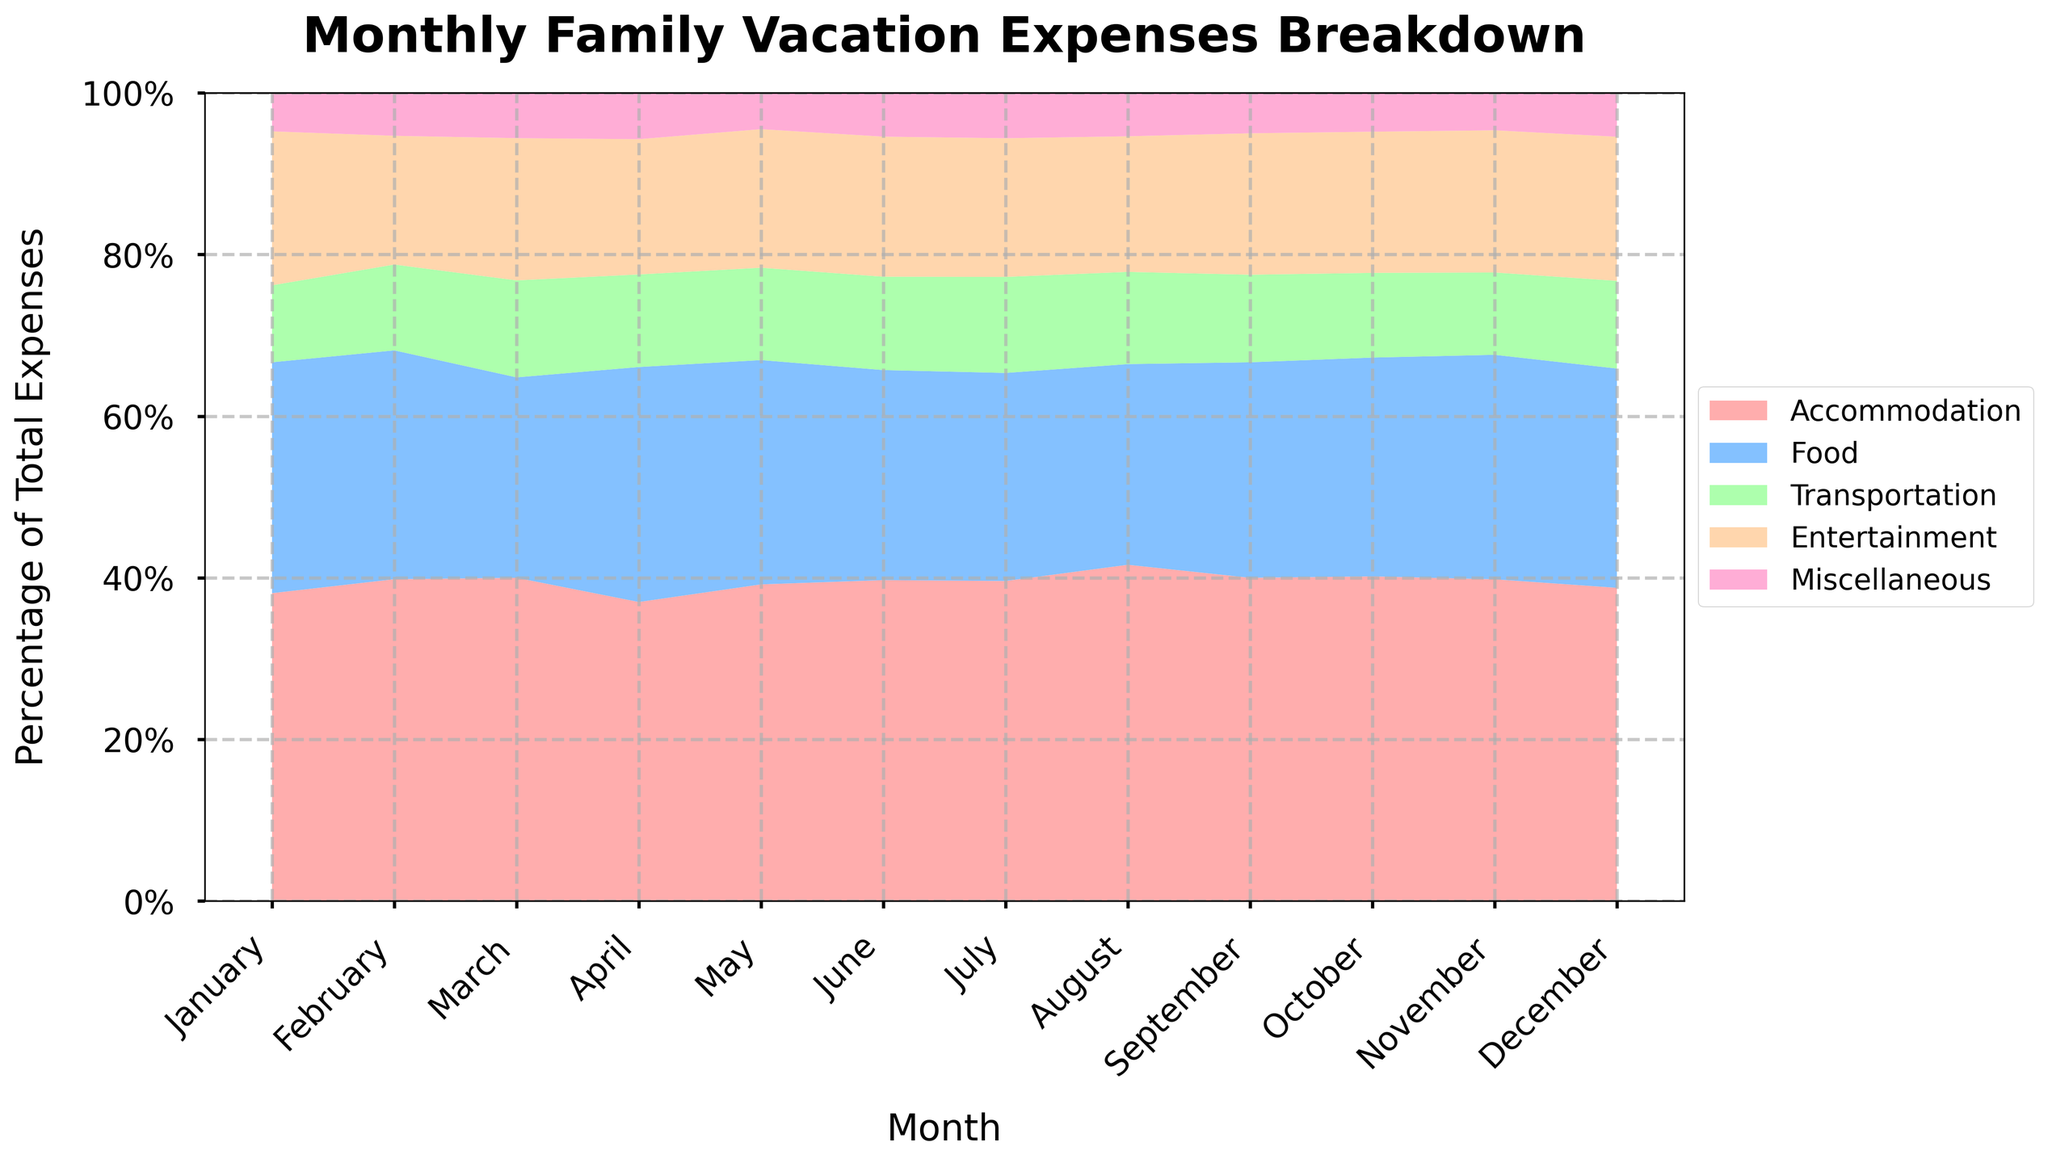What is the title of the chart? The title of the chart is typically displayed prominently at the top and it reads, "Monthly Family Vacation Expenses Breakdown".
Answer: Monthly Family Vacation Expenses Breakdown Which month has the highest percentage of expenses on Accommodation? By visual inspection, the highest percentage of the chart occupied by the Accommodation category (represented by the color red) appears in August.
Answer: August In which month did Transportation expenses take up the smallest percentage of the total expenses? Looking at the width of the Transportation band (light green), November has the thinnest segment for Transportation, indicating the smallest percentage.
Answer: November How does the percentage of Food expenses in December compare to July? By comparing the blue bands for Food in December and July, December’s Food expenses take a slightly larger percentage than in July.
Answer: December's percentage is higher What proportion of the total expenses are allocated to Miscellaneous for January? Miscellaneous expenses (pink) in January have the smallest visible segment in January, and by examining the stack, it is around 4% of the total.
Answer: 4% During which month is the percentage of Entertainment expenses the highest? By examining the orange segments, the Entertainment expense is widest in July, indicating the highest percentage for this category.
Answer: July How does the trend of Accommodation expenses change from January to December? The Accommodation expenses (red) generally increase from January to a peak in August, then decline towards December.
Answer: Increase to August, then decreases Which category sees the largest increase in percentage from June to July? By comparing band proportions, Accommodation (red) sees a significant increase from June to July, the largest among all categories.
Answer: Accommodation If you were to remove the Miscellaneous expenses, which month would have the least impact on the overall expense distribution? Examining the smallest segments for Miscellaneous across all months, January's Miscellaneous expenses have the least visual impact on the overall distribution.
Answer: January What month has nearly equal percentages of Food and Entertainment expenses? The months where blue (Food) and orange (Entertainment) bands appear nearly equal are close, and April is one such month with roughly equal bands.
Answer: April 